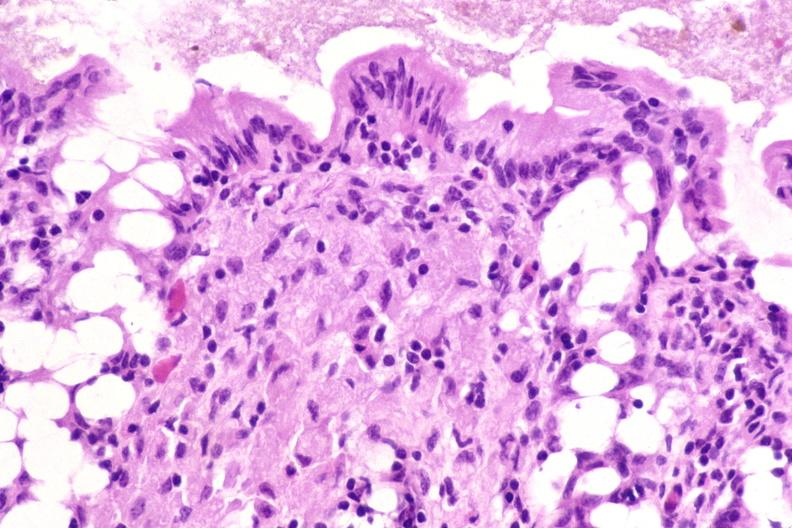does this image show colon biopsy, mycobacterium avium-intracellularae?
Answer the question using a single word or phrase. Yes 